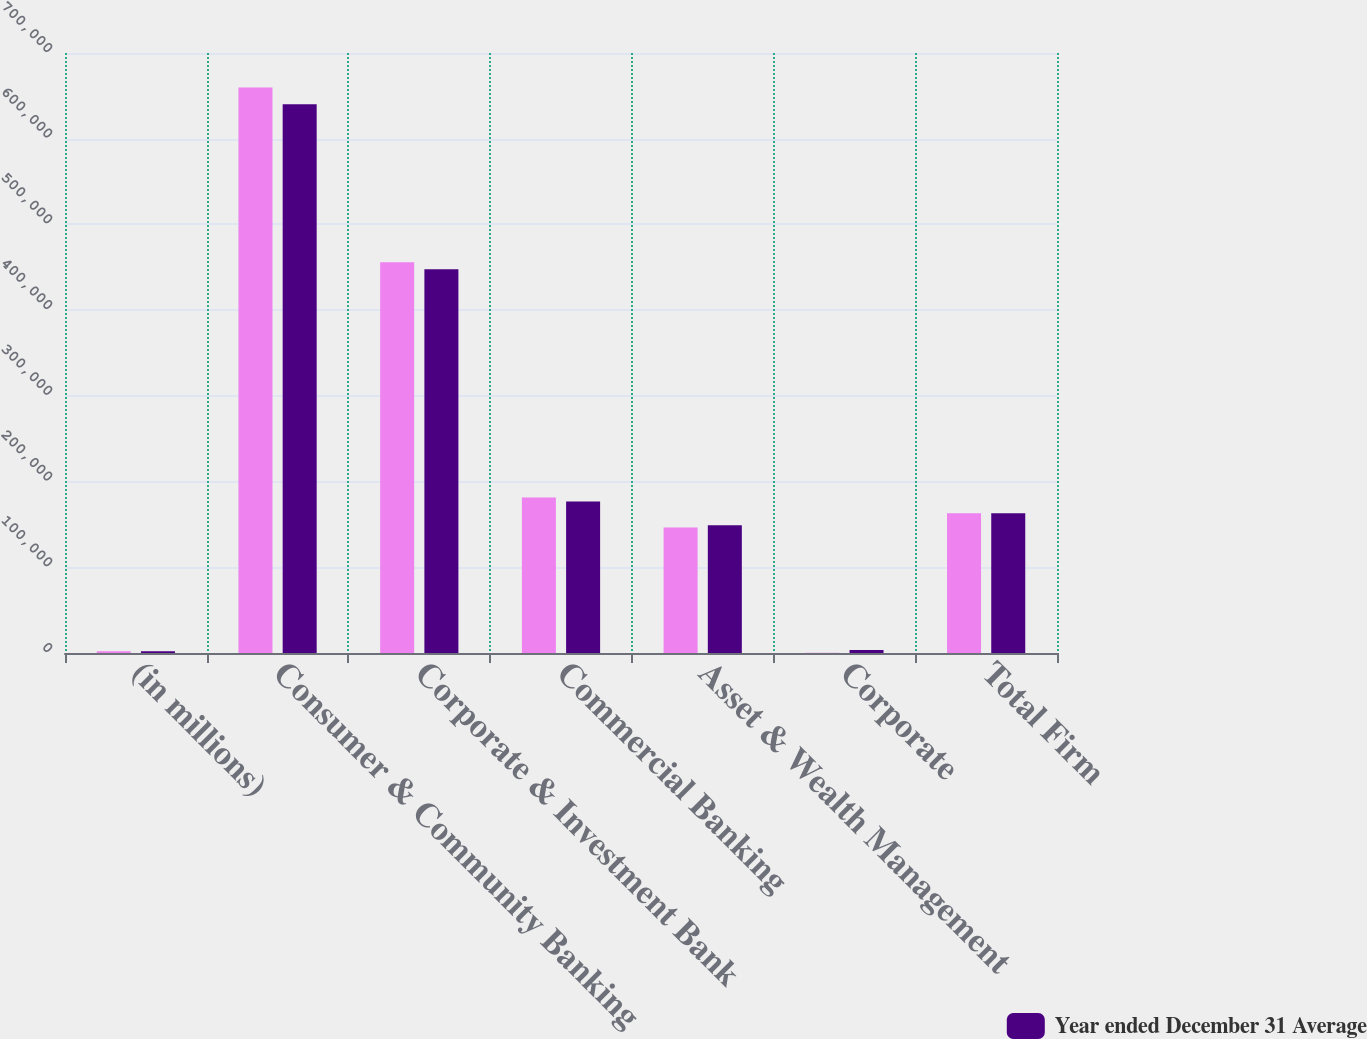<chart> <loc_0><loc_0><loc_500><loc_500><stacked_bar_chart><ecel><fcel>(in millions)<fcel>Consumer & Community Banking<fcel>Corporate & Investment Bank<fcel>Commercial Banking<fcel>Asset & Wealth Management<fcel>Corporate<fcel>Total Firm<nl><fcel>nan<fcel>2017<fcel>659885<fcel>455883<fcel>181512<fcel>146407<fcel>295<fcel>162933<nl><fcel>Year ended December 31 Average<fcel>2017<fcel>640219<fcel>447697<fcel>176884<fcel>148982<fcel>3604<fcel>162933<nl></chart> 